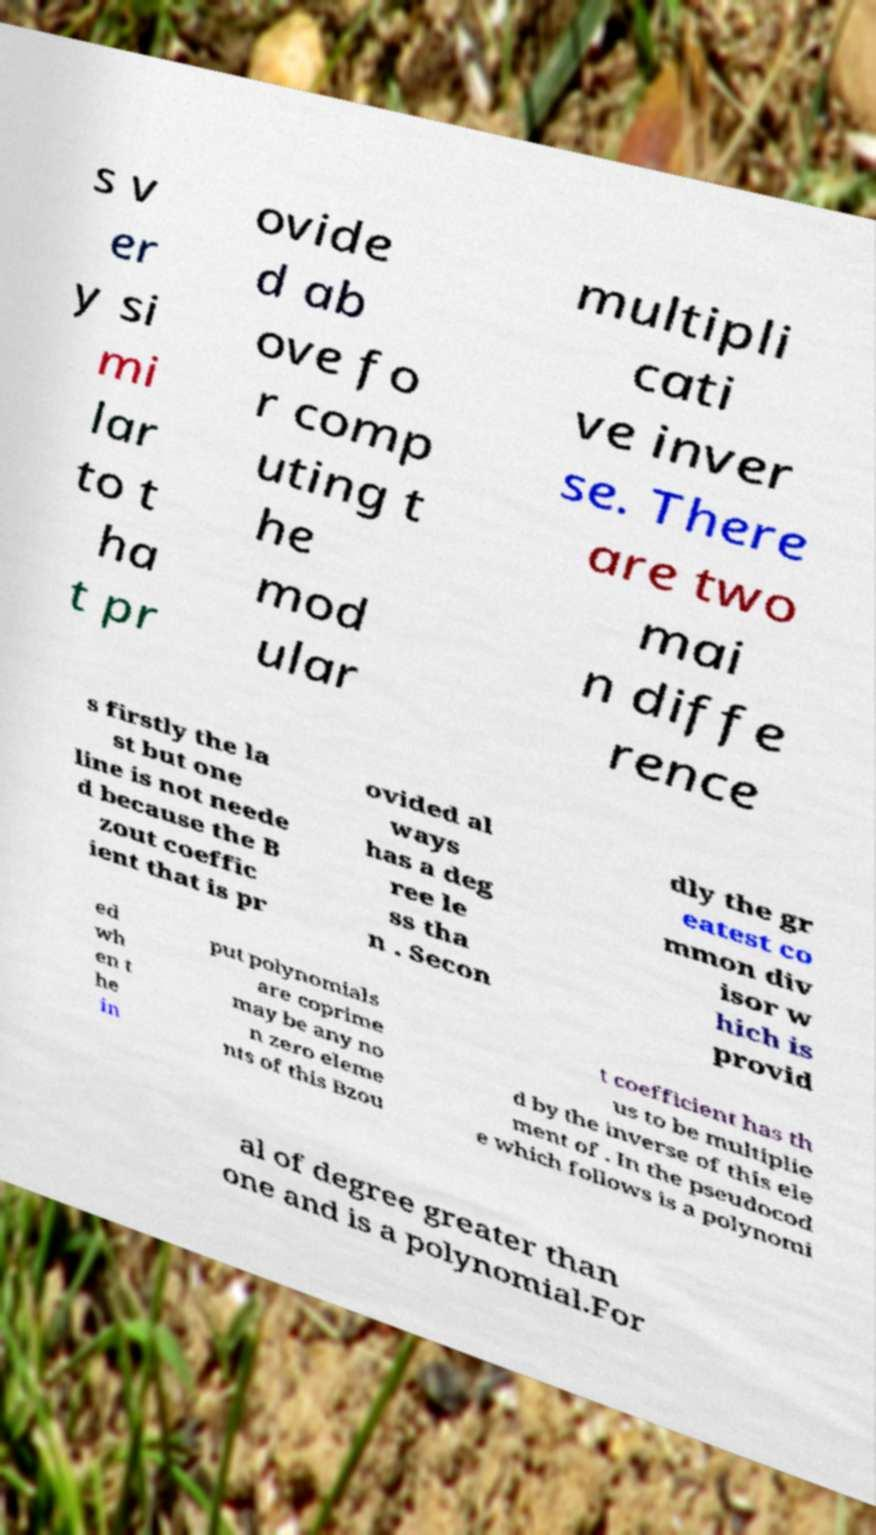For documentation purposes, I need the text within this image transcribed. Could you provide that? s v er y si mi lar to t ha t pr ovide d ab ove fo r comp uting t he mod ular multipli cati ve inver se. There are two mai n diffe rence s firstly the la st but one line is not neede d because the B zout coeffic ient that is pr ovided al ways has a deg ree le ss tha n . Secon dly the gr eatest co mmon div isor w hich is provid ed wh en t he in put polynomials are coprime may be any no n zero eleme nts of this Bzou t coefficient has th us to be multiplie d by the inverse of this ele ment of . In the pseudocod e which follows is a polynomi al of degree greater than one and is a polynomial.For 